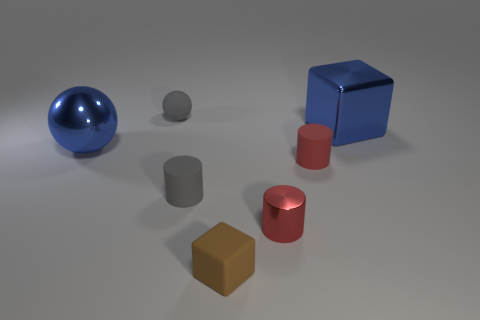There is a object that is the same color as the matte sphere; what size is it?
Offer a very short reply. Small. There is a ball that is to the left of the small matte ball; is its color the same as the large object that is to the right of the brown cube?
Your answer should be compact. Yes. What number of tiny objects are either blue shiny things or brown rubber cubes?
Your response must be concise. 1. What is the size of the other shiny object that is the same shape as the brown thing?
Ensure brevity in your answer.  Large. What material is the gray object in front of the large thing that is on the right side of the small brown rubber object?
Offer a very short reply. Rubber. How many matte objects are gray blocks or big blue cubes?
Give a very brief answer. 0. What color is the other large metallic thing that is the same shape as the brown object?
Ensure brevity in your answer.  Blue. What number of other big spheres have the same color as the metallic ball?
Keep it short and to the point. 0. Are there any tiny rubber cylinders in front of the large object that is to the right of the red shiny cylinder?
Make the answer very short. Yes. How many tiny rubber things are both behind the tiny metallic object and left of the red rubber thing?
Your answer should be compact. 2. 